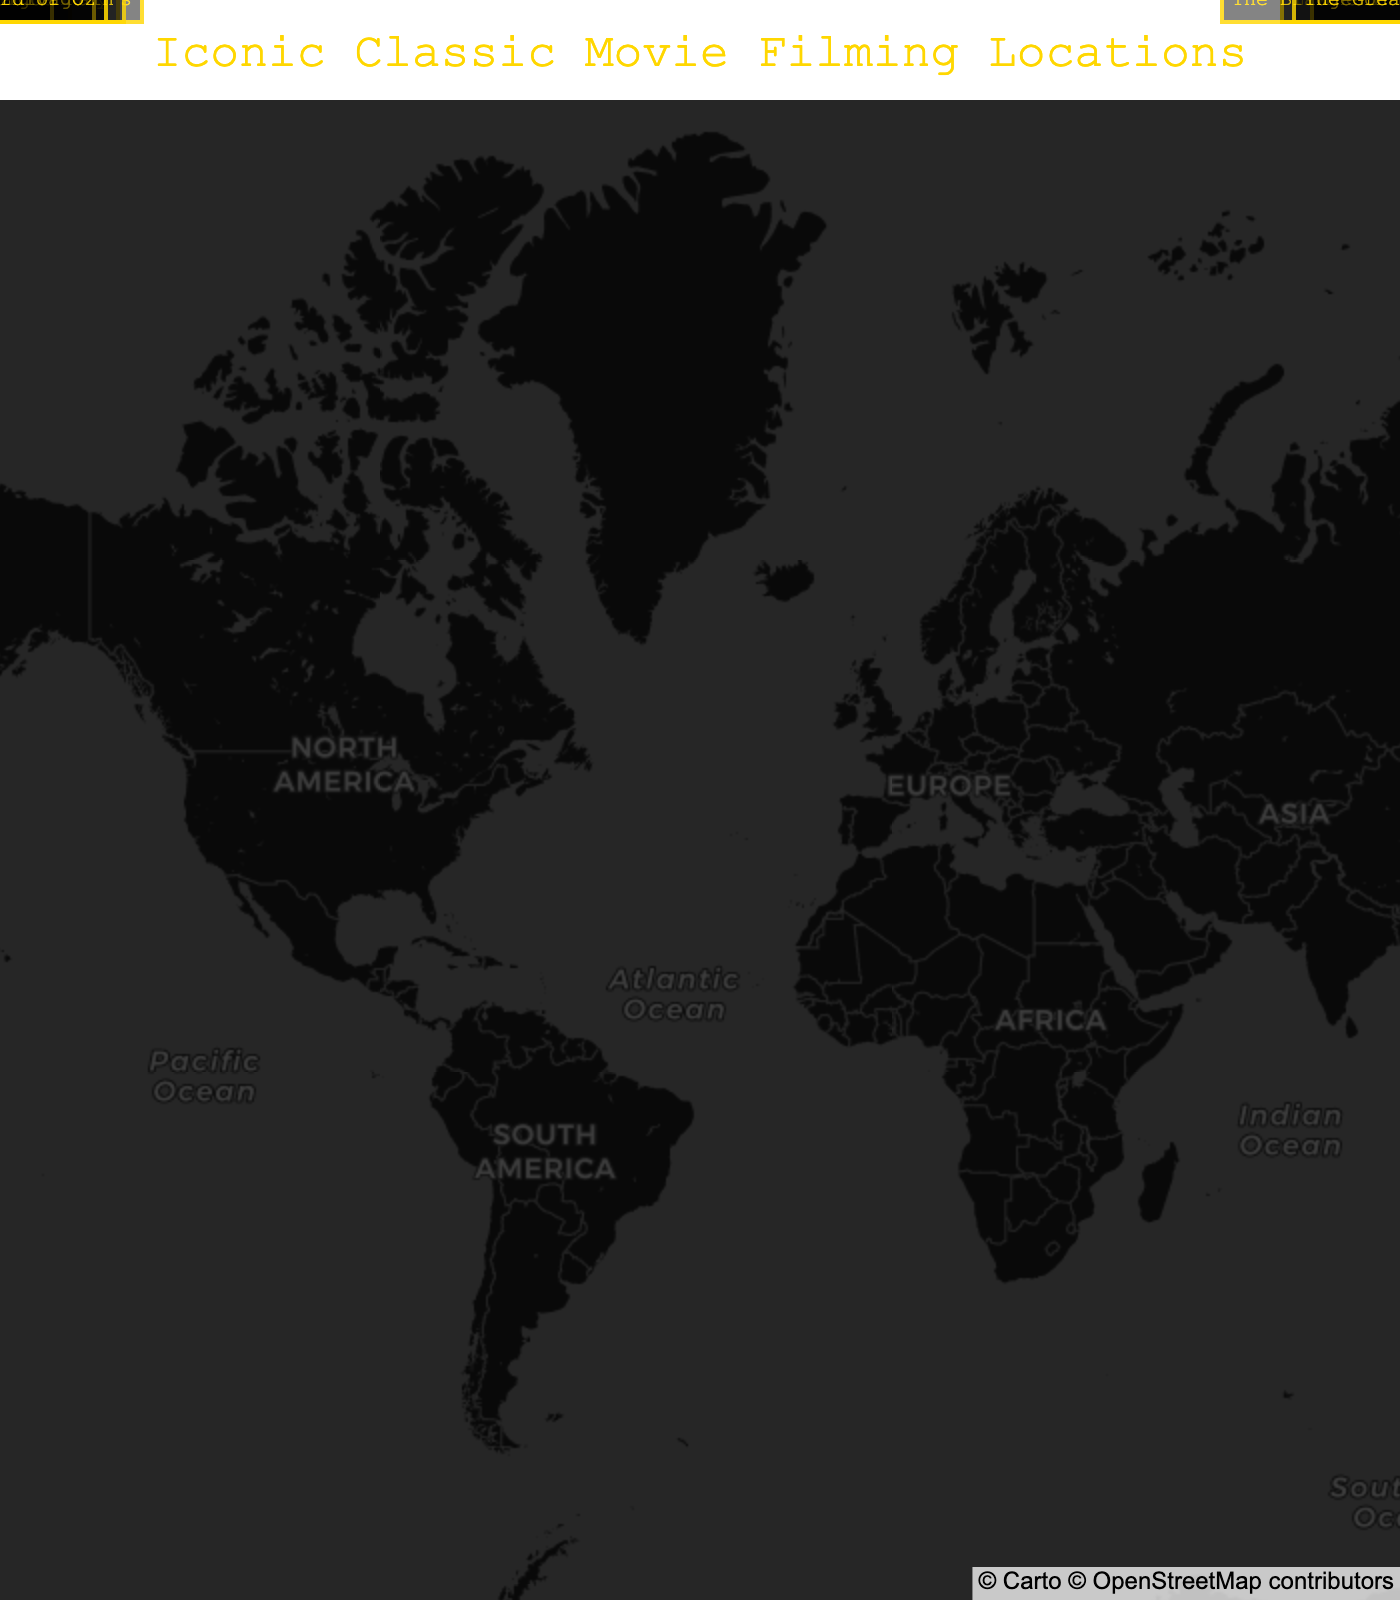What is the title of the map? The title is centered at the top of the map and reads: "Iconic Classic Movie Filming Locations".
Answer: Iconic Classic Movie Filming Locations How many filming locations are marked on the map? By counting the markers on the map, there are 13 filming locations marked.
Answer: 13 Which movie was filmed in Vienna? Locate the marker near Vienna and check the annotation. The annotation shows "The Third Man".
Answer: The Third Man Is there a filming location in Africa? Look at the map for locations on the African continent. There is one marker in Morocco.
Answer: Yes Which movie was filmed the farthest north? Check the latitudes of all the markers and find the highest one. Salzburg for "The Sound of Music" at 47.8095 is the farthest north.
Answer: The Sound of Music Which two movies were filmed closest to each other? Find the two markers that are geographically closest. Los Angeles (Singin' in the Rain) and Culver City (The Wizard of Oz) are geographically closest.
Answer: Singin' in the Rain, The Wizard of Oz What filming location is associated with "Gone with the Wind"? Find the marker with the annotation for "Gone with the Wind" which is located in Atlanta.
Answer: Atlanta Which movie filming location is found in the Middle East? Locate the marker in the Middle East region (Wadi Rum) and check the annotation. It shows "Lawrence of Arabia".
Answer: Lawrence of Arabia Which two movies were filmed in Italy? Locate the markers in Italy and check the annotations. Both "Roman Holiday" and "The Third Man" were filmed there (ensure to distinguish based on geographic location). Note: Only "Roman Holiday" is filmed in Italy.
Answer: Roman Holiday 